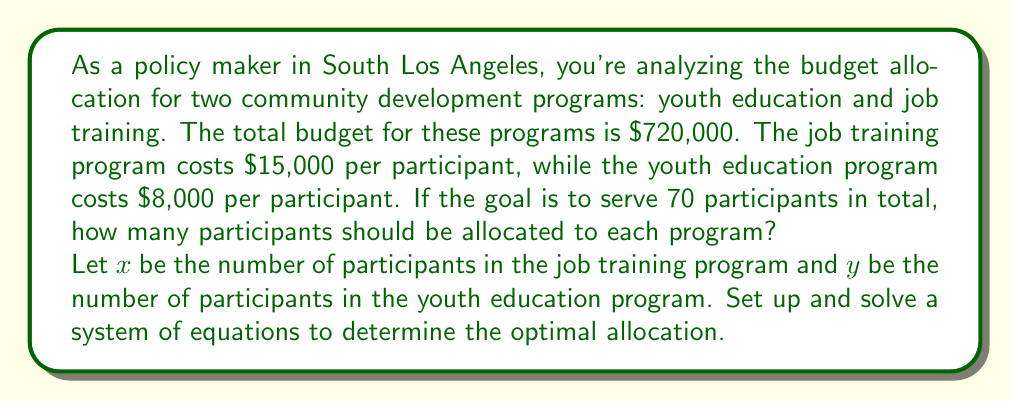Teach me how to tackle this problem. Let's approach this step-by-step:

1) First, we need to set up our system of equations based on the given information:

   Equation 1 (Total participants): $x + y = 70$
   Equation 2 (Total budget): $15000x + 8000y = 720000$

2) We can solve this system using substitution method. Let's start by expressing $y$ in terms of $x$ from Equation 1:

   $y = 70 - x$

3) Now, substitute this expression for $y$ into Equation 2:

   $15000x + 8000(70 - x) = 720000$

4) Simplify:

   $15000x + 560000 - 8000x = 720000$
   $7000x + 560000 = 720000$

5) Subtract 560000 from both sides:

   $7000x = 160000$

6) Divide both sides by 7000:

   $x = \frac{160000}{7000} = \frac{160}{7} \approx 22.86$

7) Since we can't have a fractional number of participants, we round down to 22 participants for the job training program.

8) To find $y$, substitute $x = 22$ into Equation 1:

   $y = 70 - 22 = 48$

9) Verify the solution:
   22 + 48 = 70 (total participants)
   $15000(22) + 8000(48) = 330000 + 384000 = 714000$ (slightly under budget, which is acceptable)

Therefore, the optimal allocation is 22 participants for the job training program and 48 participants for the youth education program.
Answer: 22 participants for job training, 48 for youth education 